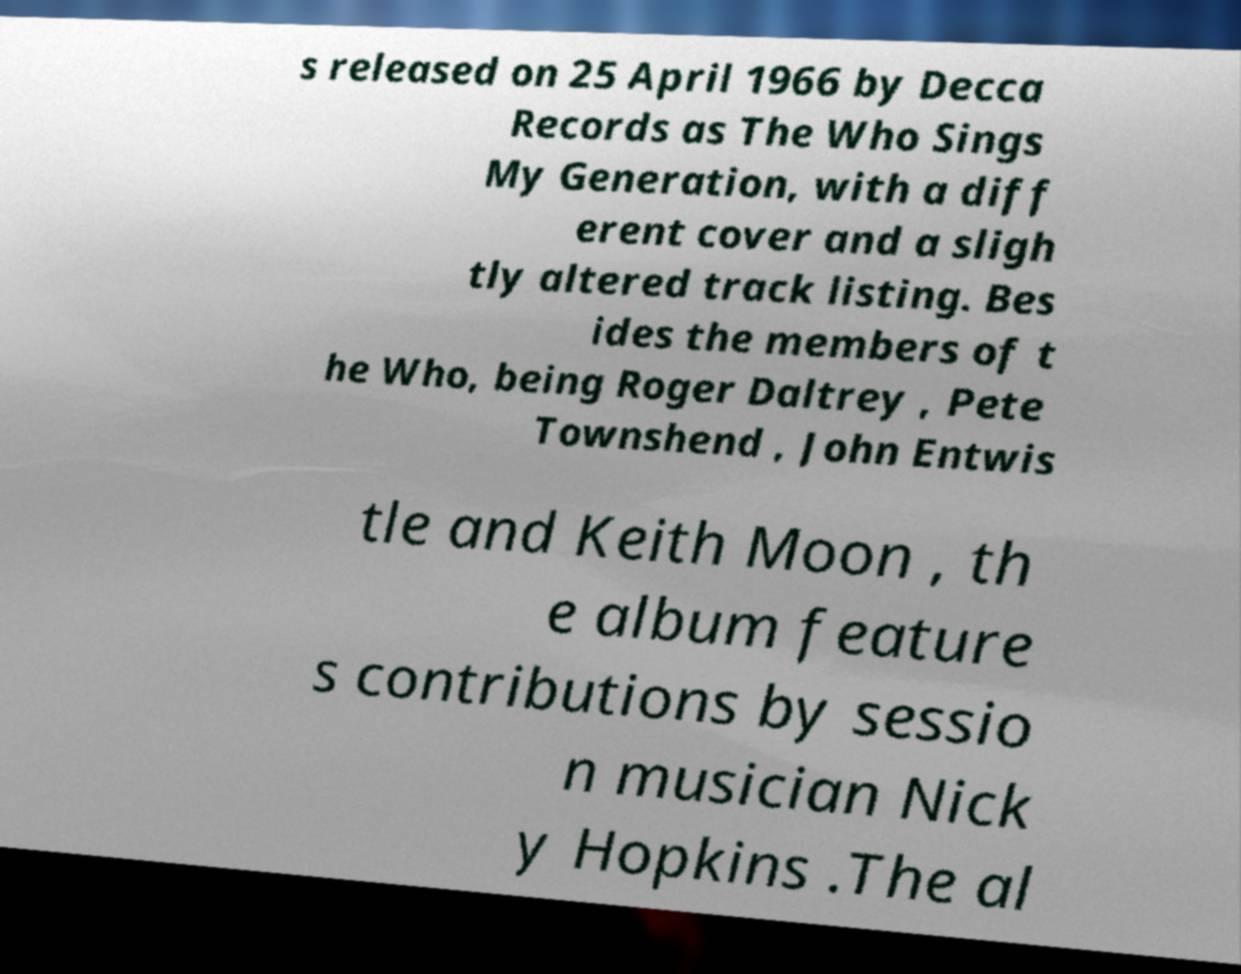I need the written content from this picture converted into text. Can you do that? s released on 25 April 1966 by Decca Records as The Who Sings My Generation, with a diff erent cover and a sligh tly altered track listing. Bes ides the members of t he Who, being Roger Daltrey , Pete Townshend , John Entwis tle and Keith Moon , th e album feature s contributions by sessio n musician Nick y Hopkins .The al 